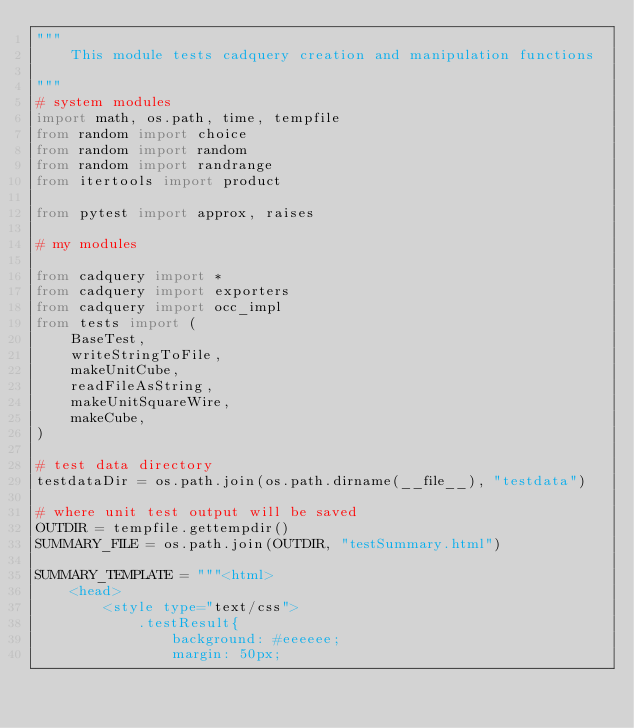<code> <loc_0><loc_0><loc_500><loc_500><_Python_>"""
    This module tests cadquery creation and manipulation functions

"""
# system modules
import math, os.path, time, tempfile
from random import choice
from random import random
from random import randrange
from itertools import product

from pytest import approx, raises

# my modules

from cadquery import *
from cadquery import exporters
from cadquery import occ_impl
from tests import (
    BaseTest,
    writeStringToFile,
    makeUnitCube,
    readFileAsString,
    makeUnitSquareWire,
    makeCube,
)

# test data directory
testdataDir = os.path.join(os.path.dirname(__file__), "testdata")

# where unit test output will be saved
OUTDIR = tempfile.gettempdir()
SUMMARY_FILE = os.path.join(OUTDIR, "testSummary.html")

SUMMARY_TEMPLATE = """<html>
    <head>
        <style type="text/css">
            .testResult{
                background: #eeeeee;
                margin: 50px;</code> 